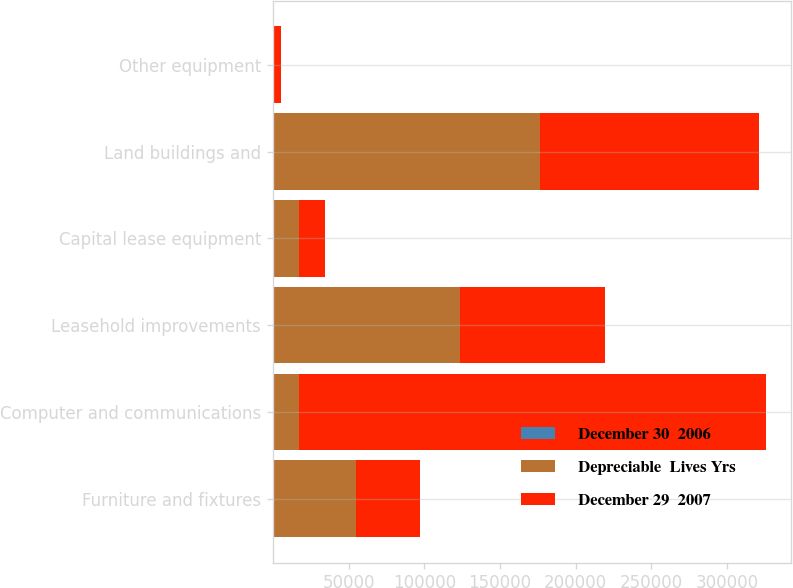<chart> <loc_0><loc_0><loc_500><loc_500><stacked_bar_chart><ecel><fcel>Furniture and fixtures<fcel>Computer and communications<fcel>Leasehold improvements<fcel>Capital lease equipment<fcel>Land buildings and<fcel>Other equipment<nl><fcel>December 30  2006<fcel>5<fcel>2<fcel>2<fcel>3<fcel>12<fcel>5<nl><fcel>Depreciable  Lives Yrs<fcel>55016<fcel>17333<fcel>123799<fcel>17416<fcel>176216<fcel>983<nl><fcel>December 29  2007<fcel>41914<fcel>308370<fcel>95433<fcel>17333<fcel>144820<fcel>4299<nl></chart> 